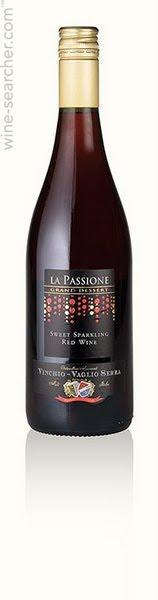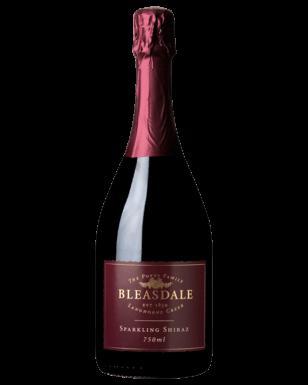The first image is the image on the left, the second image is the image on the right. Evaluate the accuracy of this statement regarding the images: "One image shows only part of one wine glass and part of one bottle of wine.". Is it true? Answer yes or no. No. The first image is the image on the left, the second image is the image on the right. Considering the images on both sides, is "There are 2 bottles of wine standing upright." valid? Answer yes or no. Yes. 